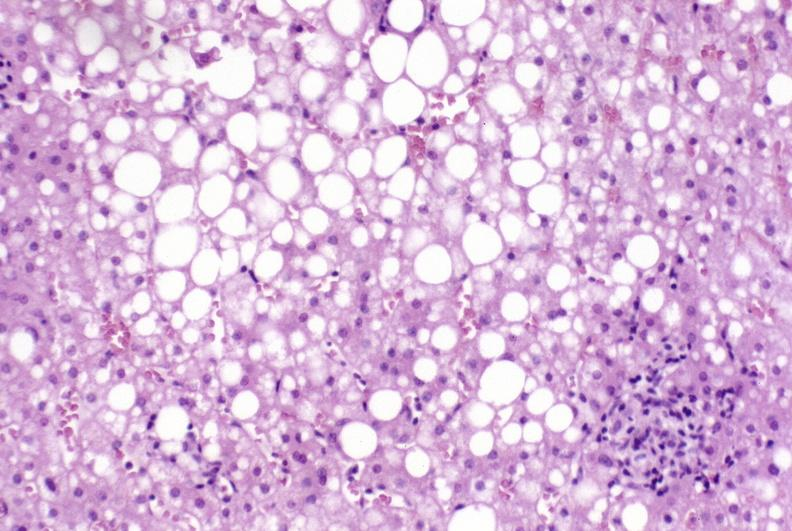s intraductal papillomatosis with apocrine metaplasia present?
Answer the question using a single word or phrase. No 